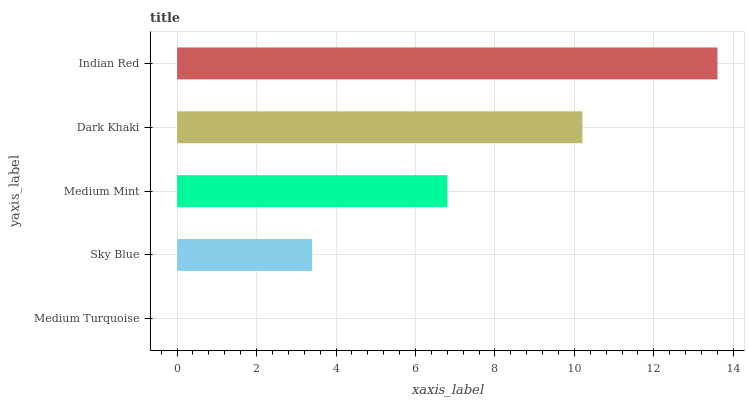Is Medium Turquoise the minimum?
Answer yes or no. Yes. Is Indian Red the maximum?
Answer yes or no. Yes. Is Sky Blue the minimum?
Answer yes or no. No. Is Sky Blue the maximum?
Answer yes or no. No. Is Sky Blue greater than Medium Turquoise?
Answer yes or no. Yes. Is Medium Turquoise less than Sky Blue?
Answer yes or no. Yes. Is Medium Turquoise greater than Sky Blue?
Answer yes or no. No. Is Sky Blue less than Medium Turquoise?
Answer yes or no. No. Is Medium Mint the high median?
Answer yes or no. Yes. Is Medium Mint the low median?
Answer yes or no. Yes. Is Sky Blue the high median?
Answer yes or no. No. Is Indian Red the low median?
Answer yes or no. No. 